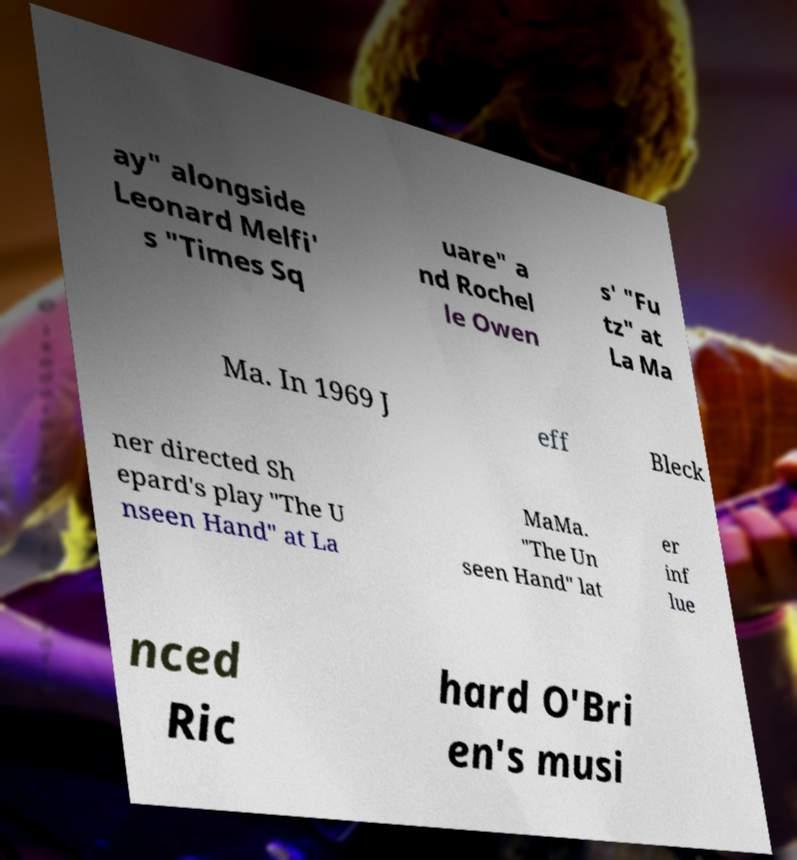Can you read and provide the text displayed in the image?This photo seems to have some interesting text. Can you extract and type it out for me? ay" alongside Leonard Melfi' s "Times Sq uare" a nd Rochel le Owen s' "Fu tz" at La Ma Ma. In 1969 J eff Bleck ner directed Sh epard's play "The U nseen Hand" at La MaMa. "The Un seen Hand" lat er inf lue nced Ric hard O'Bri en's musi 